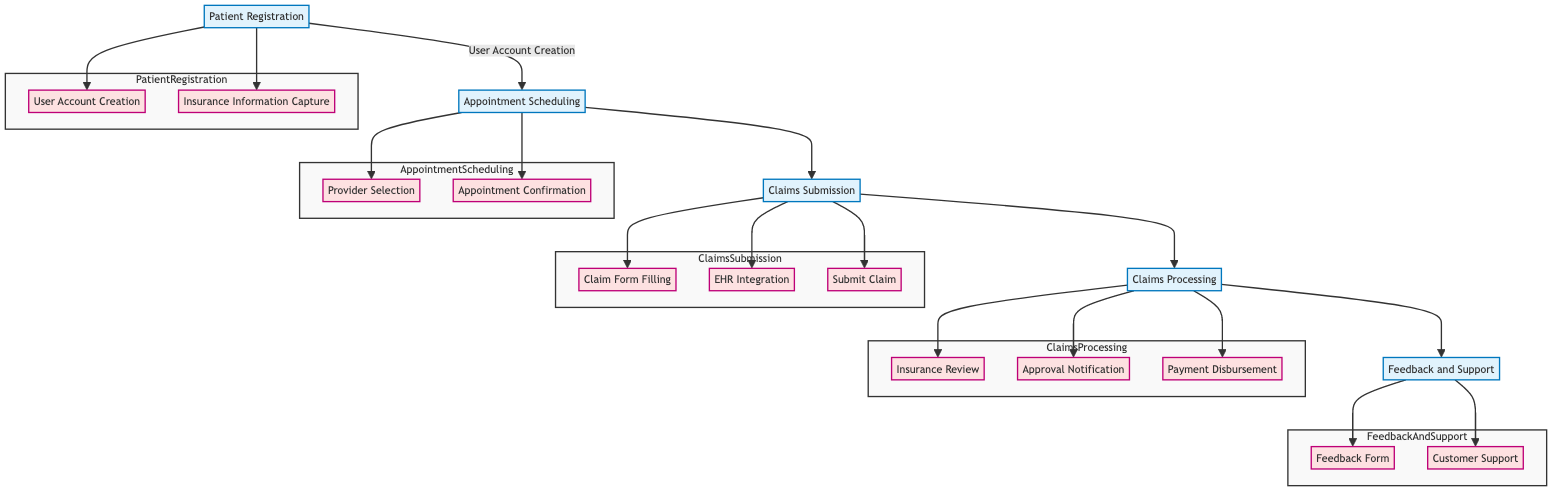What is the first step in the clinical pathway? The first step is the "Patient Registration" node, which initiates the clinical pathway process. It is the starting point that leads to subsequent nodes in the diagram.
Answer: Patient Registration How many components are in the Claims Submission stage? In the Claims Submission stage, there are three components: Claim Form Filling, EHR Integration, and Submit Claim. Count them directly from the diagram to arrive at the answer.
Answer: Three What subsystem is associated with Payment Disbursement? The subsystem associated with Payment Disbursement is "Financial," as indicated directly beneath the component in the diagram.
Answer: Financial Which node follows Appointment Scheduling? The node that follows Appointment Scheduling is "Claims Submission." This sequential flow is shown by the directed edge leading from Appointment Scheduling to Claims Submission in the diagram.
Answer: Claims Submission What tasks are included in User Account Creation? The tasks included in User Account Creation are "Email Verification" and "User Profile Setup." These are explicitly listed under the component in the diagram.
Answer: Email Verification, User Profile Setup How many types of notifications are sent during Claims Processing? During Claims Processing, there are two types of notifications sent: "Email Status Update" and "Detailed Report." These tasks are specified under the Approval Notification component.
Answer: Two What is the terminal step in the clinical pathway? The terminal step in the clinical pathway is "Feedback and Support," which is the final node where patients provide feedback after the claims process.
Answer: Feedback and Support Which components are exclusively part of the Patient Registration? The components exclusively part of the Patient Registration are "User Account Creation" and "Insurance Information Capture." These two components are specific to this stage and do not appear in other stages.
Answer: User Account Creation, Insurance Information Capture What is the focus of the Feedback And Support stage? The focus of the Feedback And Support stage is to gather patient feedback on the claims process and provide necessary support through customer service options. This is evident from the available components.
Answer: Patient feedback and support 